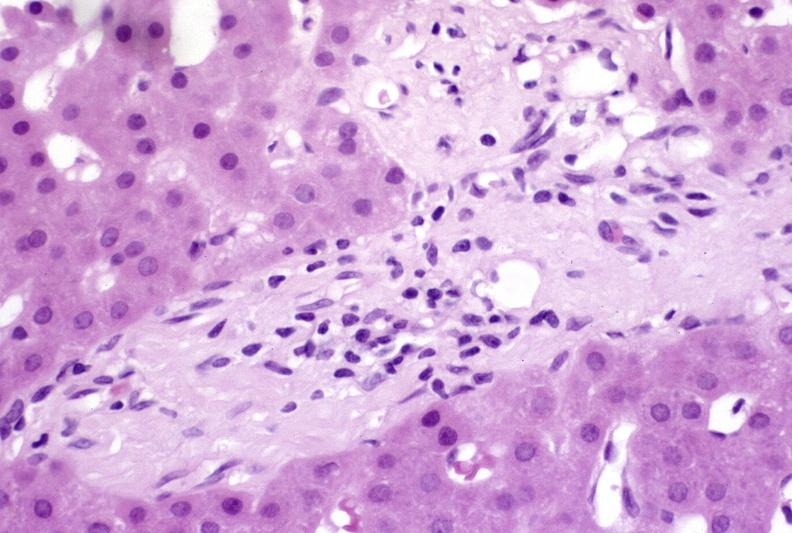does this image show ductopenia?
Answer the question using a single word or phrase. Yes 